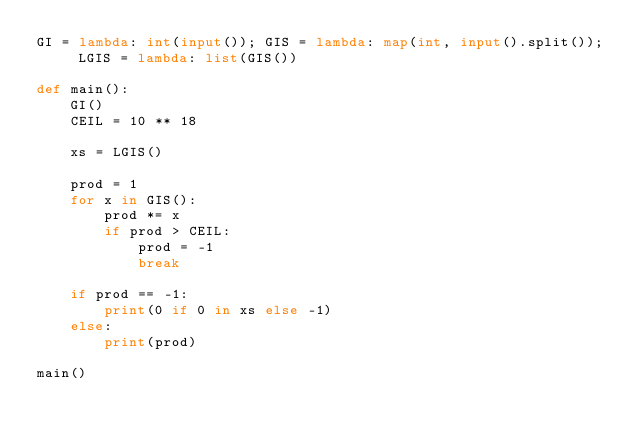<code> <loc_0><loc_0><loc_500><loc_500><_Python_>GI = lambda: int(input()); GIS = lambda: map(int, input().split()); LGIS = lambda: list(GIS())

def main():
    GI()
    CEIL = 10 ** 18

    xs = LGIS()

    prod = 1
    for x in GIS():
        prod *= x
        if prod > CEIL:
            prod = -1
            break

    if prod == -1:
        print(0 if 0 in xs else -1)
    else:
        print(prod)

main()
</code> 